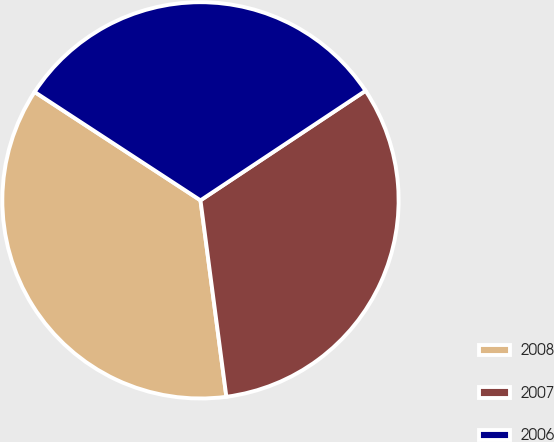Convert chart to OTSL. <chart><loc_0><loc_0><loc_500><loc_500><pie_chart><fcel>2008<fcel>2007<fcel>2006<nl><fcel>36.3%<fcel>32.24%<fcel>31.46%<nl></chart> 